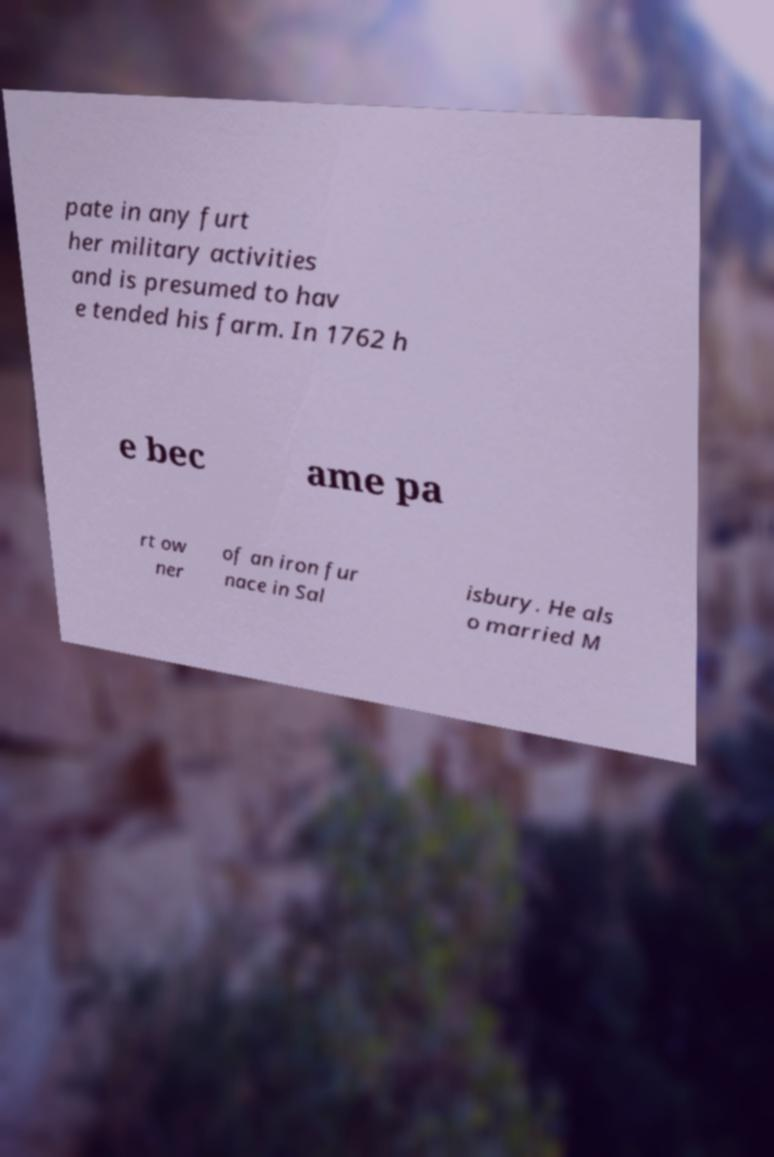Can you accurately transcribe the text from the provided image for me? pate in any furt her military activities and is presumed to hav e tended his farm. In 1762 h e bec ame pa rt ow ner of an iron fur nace in Sal isbury. He als o married M 